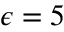Convert formula to latex. <formula><loc_0><loc_0><loc_500><loc_500>\epsilon = 5</formula> 